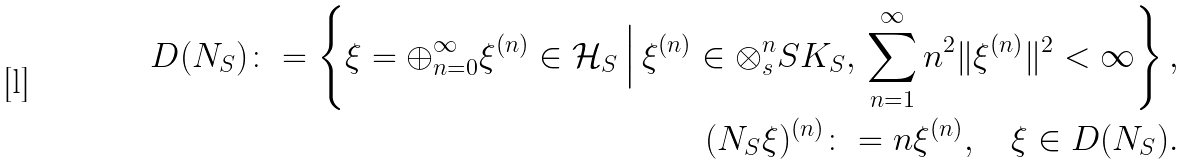<formula> <loc_0><loc_0><loc_500><loc_500>D ( N _ { S } ) \colon = \left \{ \xi = \oplus _ { n = 0 } ^ { \infty } \xi ^ { ( n ) } \in \mathcal { H } _ { S } \, \Big | \, \xi ^ { ( n ) } \in \otimes _ { s } ^ { n } S K _ { S } , \, \sum _ { n = 1 } ^ { \infty } n ^ { 2 } \| \xi ^ { ( n ) } \| ^ { 2 } < \infty \right \} , \\ ( N _ { S } \xi ) ^ { ( n ) } \colon = n \xi ^ { ( n ) } , \quad \xi \in D ( N _ { S } ) .</formula> 